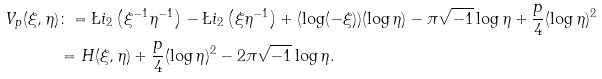Convert formula to latex. <formula><loc_0><loc_0><loc_500><loc_500>V _ { p } ( \xi , \eta ) & \colon = \L i _ { 2 } \left ( \xi ^ { - 1 } \eta ^ { - 1 } \right ) - \L i _ { 2 } \left ( \xi \eta ^ { - 1 } \right ) + ( \log ( - \xi ) ) ( \log { \eta } ) - \pi \sqrt { - 1 } \log \eta + \frac { p } { 4 } ( \log { \eta } ) ^ { 2 } \\ & = H ( \xi , \eta ) + \frac { p } { 4 } ( \log { \eta } ) ^ { 2 } - 2 \pi \sqrt { - 1 } \log \eta .</formula> 